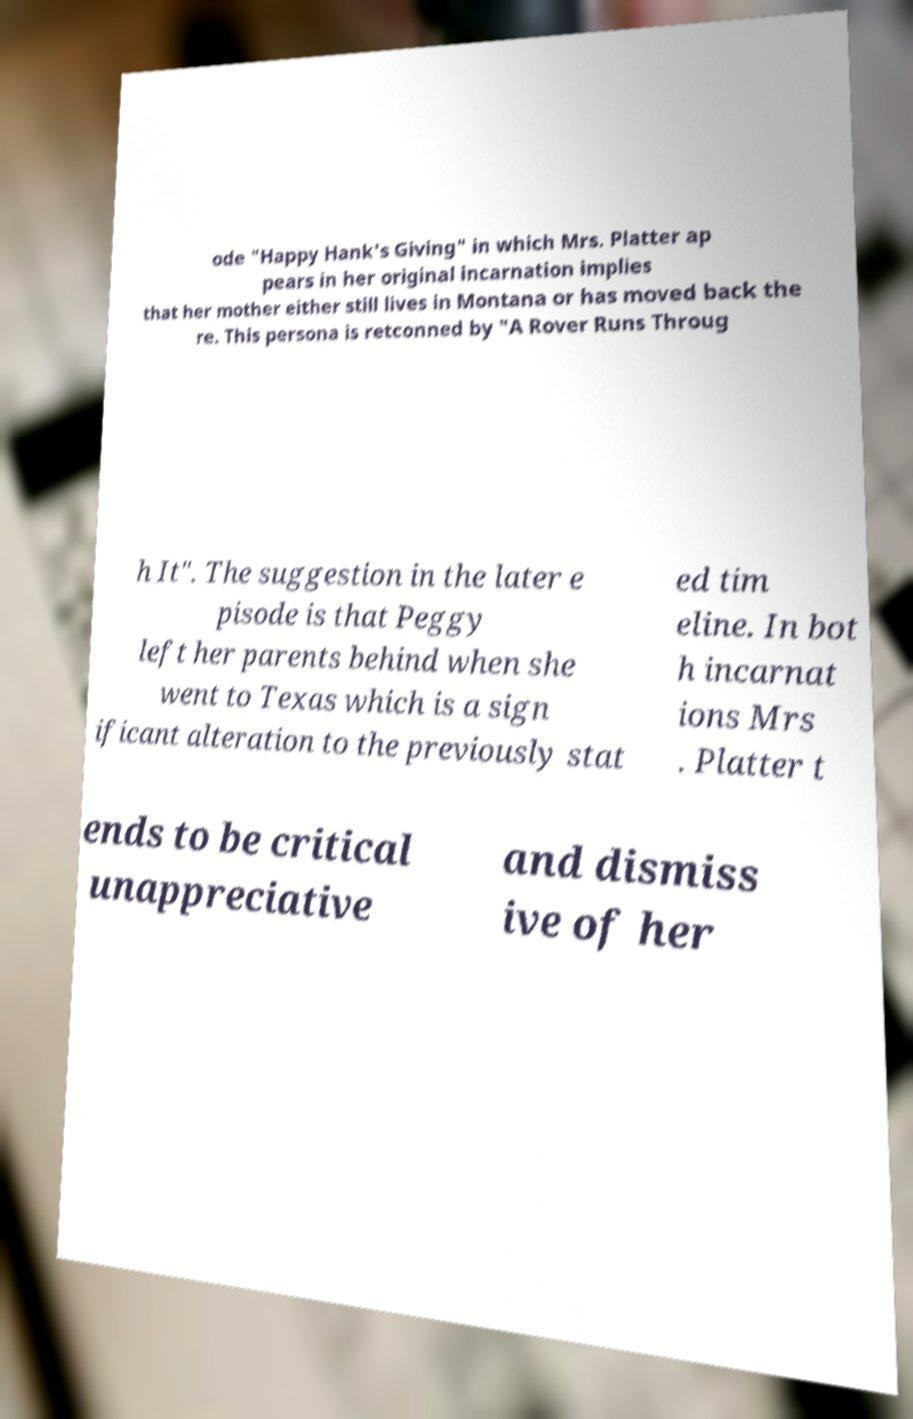Can you accurately transcribe the text from the provided image for me? ode "Happy Hank's Giving" in which Mrs. Platter ap pears in her original incarnation implies that her mother either still lives in Montana or has moved back the re. This persona is retconned by "A Rover Runs Throug h It". The suggestion in the later e pisode is that Peggy left her parents behind when she went to Texas which is a sign ificant alteration to the previously stat ed tim eline. In bot h incarnat ions Mrs . Platter t ends to be critical unappreciative and dismiss ive of her 